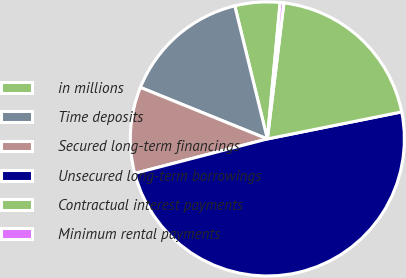Convert chart. <chart><loc_0><loc_0><loc_500><loc_500><pie_chart><fcel>in millions<fcel>Time deposits<fcel>Secured long-term financings<fcel>Unsecured long-term borrowings<fcel>Contractual interest payments<fcel>Minimum rental payments<nl><fcel>5.31%<fcel>15.04%<fcel>10.18%<fcel>49.11%<fcel>19.91%<fcel>0.44%<nl></chart> 